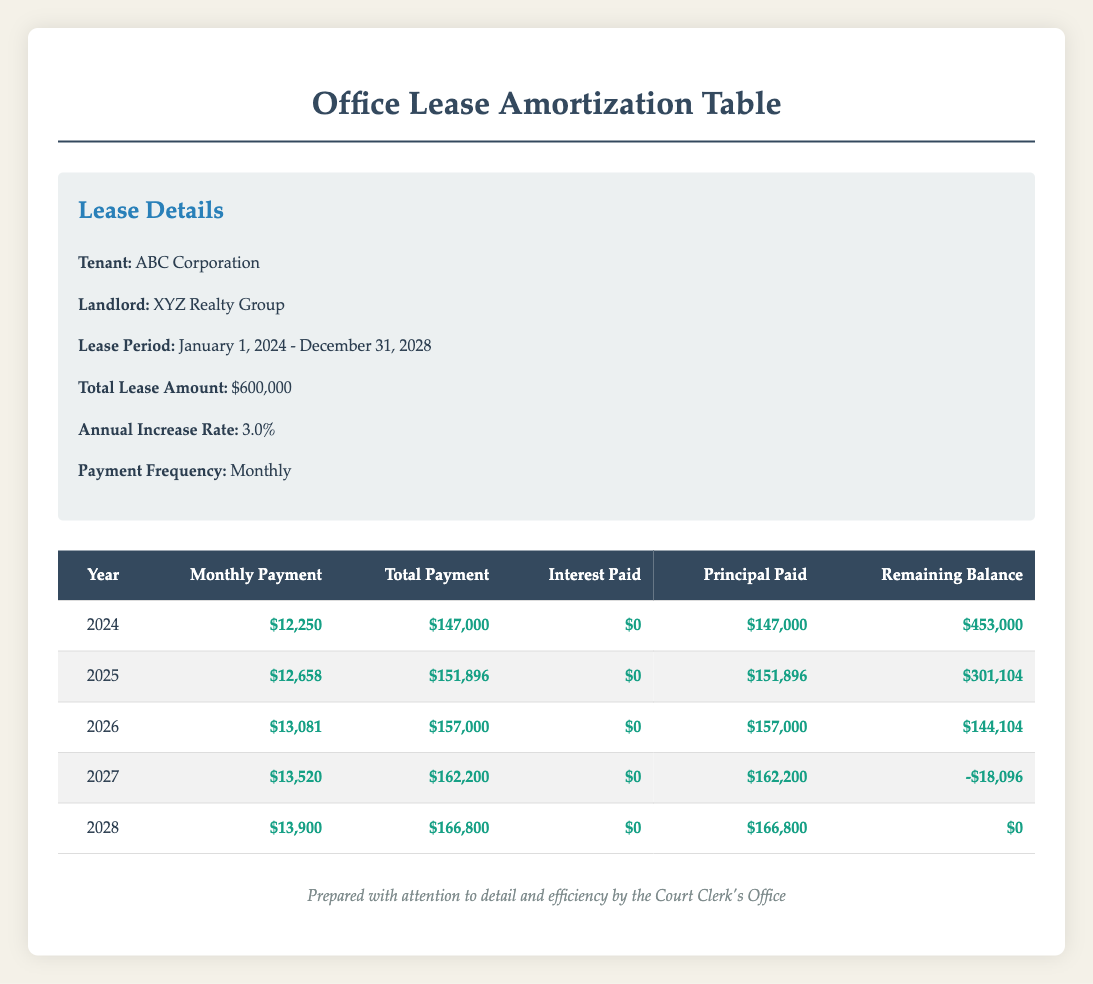What is the monthly payment for the year 2025? The monthly payment for 2025 is listed directly in the table under the 'Monthly Payment' column for that year. The specific value is $12,658.
Answer: $12,658 How much total payment was made in 2026? According to the table, the total payment for the year 2026 is in the 'Total Payment' column for that year, which is $157,000.
Answer: $157,000 Is there any interest paid over the entire lease period? The table consistently shows that the 'Interest Paid' entry for all years is $0, implying that no interest was incurred throughout the entire lease period.
Answer: Yes What was the principal paid in the year 2027? In the year 2027, the 'Principal Paid' entry in the table indicates the amount, which is $162,200.
Answer: $162,200 What is the total payment over the entire lease period? To find the total payment over the lease period, sum up the 'Total Payment' values for each year: 147,000 + 151,896 + 157,000 + 162,200 + 166,800 = 785,896.
Answer: $785,896 During which year did the remaining balance first show a negative value? By checking the 'Remaining Balance' for each year, we find that it becomes negative in 2027, where the value is -$18,096.
Answer: 2027 What is the monthly payment increase from 2024 to 2025? To find the increase, we subtract the monthly payment of 2024 ($12,250) from that of 2025 ($12,658): $12,658 - $12,250 = $408.
Answer: $408 Calculate the average monthly payment over the 5-year lease period. To calculate the average monthly payment, sum the monthly payments for each year: (12,250 + 12,658 + 13,081 + 13,520 + 13,900) = 65,399. Then divide by 5: 65,399 / 5 = 13,079.8. The average monthly payment is approximately $13,079.80.
Answer: $13,079.80 